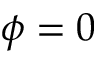<formula> <loc_0><loc_0><loc_500><loc_500>\phi = 0</formula> 